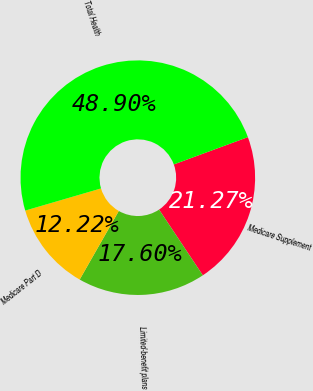Convert chart to OTSL. <chart><loc_0><loc_0><loc_500><loc_500><pie_chart><fcel>Medicare Supplement<fcel>Limited-benefit plans<fcel>Medicare Part D<fcel>Total Health<nl><fcel>21.27%<fcel>17.6%<fcel>12.22%<fcel>48.9%<nl></chart> 